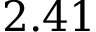Convert formula to latex. <formula><loc_0><loc_0><loc_500><loc_500>2 . 4 1</formula> 